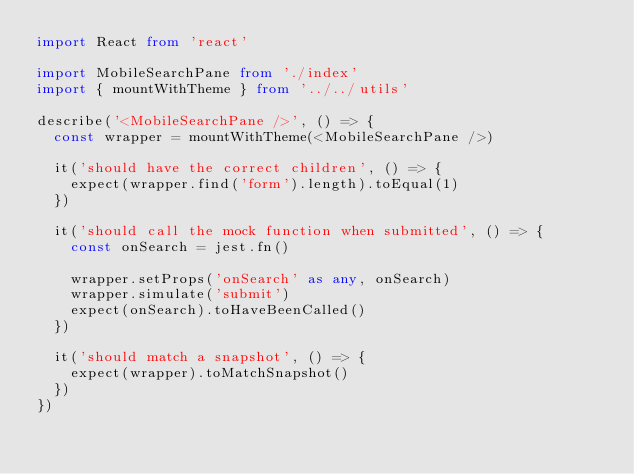<code> <loc_0><loc_0><loc_500><loc_500><_TypeScript_>import React from 'react'

import MobileSearchPane from './index'
import { mountWithTheme } from '../../utils'

describe('<MobileSearchPane />', () => {
  const wrapper = mountWithTheme(<MobileSearchPane />)

  it('should have the correct children', () => {
    expect(wrapper.find('form').length).toEqual(1)
  })

  it('should call the mock function when submitted', () => {
    const onSearch = jest.fn()

    wrapper.setProps('onSearch' as any, onSearch)
    wrapper.simulate('submit')
    expect(onSearch).toHaveBeenCalled()
  })

  it('should match a snapshot', () => {
    expect(wrapper).toMatchSnapshot()
  })
})
</code> 